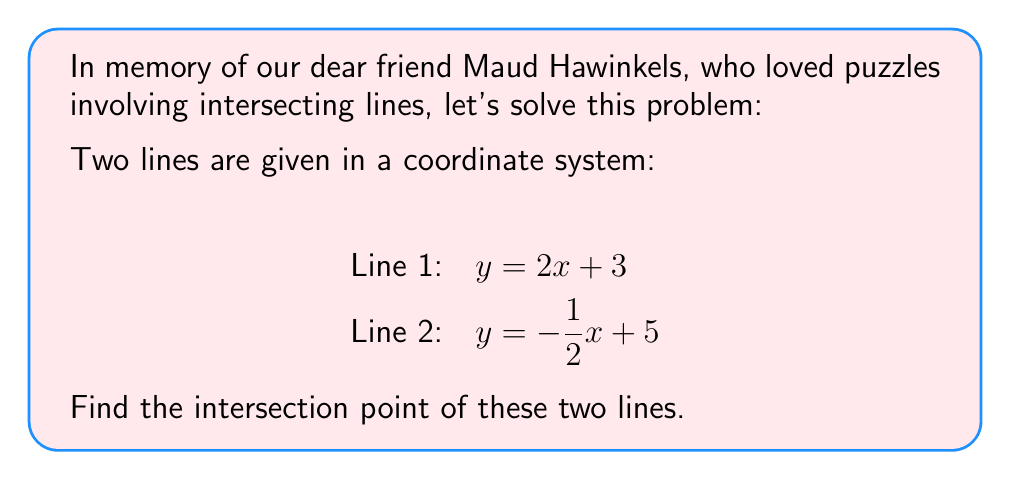Can you answer this question? To find the intersection point of two lines, we need to solve the system of equations formed by the two line equations. Let's approach this step-by-step:

1) We have two equations:
   $y = 2x + 3$ (Line 1)
   $y = -\frac{1}{2}x + 5$ (Line 2)

2) At the intersection point, the y-coordinates will be equal. So we can set the right sides of these equations equal to each other:

   $2x + 3 = -\frac{1}{2}x + 5$

3) Now, let's solve this equation for x:
   $2x + 3 = -\frac{1}{2}x + 5$
   $2x + \frac{1}{2}x = 5 - 3$
   $\frac{5}{2}x = 2$
   $x = \frac{4}{5} = 0.8$

4) Now that we know the x-coordinate of the intersection point, we can find the y-coordinate by plugging this x-value into either of the original line equations. Let's use Line 1:

   $y = 2x + 3$
   $y = 2(0.8) + 3$
   $y = 1.6 + 3 = 4.6$

5) Therefore, the intersection point is (0.8, 4.6).

[asy]
import geometry;

size(200);
real xmin = -1, xmax = 3, ymin = 0, ymax = 7;
draw((xmin,0)--(xmax,0),arrow=Arrow(TeXHead));
draw((0,ymin)--(0,ymax),arrow=Arrow(TeXHead));

draw((xmin,2*xmin+3)--(xmax,2*xmax+3),blue);
draw((xmin,-0.5*xmin+5)--(xmax,-0.5*xmax+5),red);

dot((0.8,4.6),filltype=FillDraw(green));
label("(0.8, 4.6)", (0.8,4.6), NE);

label("x", (xmax,0), E);
label("y", (0,ymax), N);
label("y = 2x + 3", (2,7), NW, blue);
label("y = -1/2x + 5", (-0.5,5.25), NW, red);
[/asy]
Answer: The intersection point of the two lines is (0.8, 4.6). 